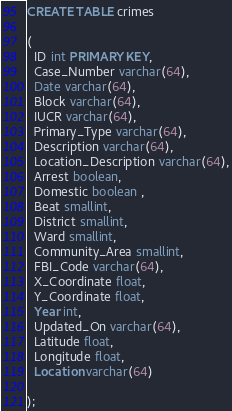Convert code to text. <code><loc_0><loc_0><loc_500><loc_500><_SQL_>CREATE TABLE crimes

(
  ID int PRIMARY KEY,
  Case_Number varchar(64),
  Date varchar(64),
  Block varchar(64),
  IUCR varchar(64),
  Primary_Type varchar(64),
  Description varchar(64),
  Location_Description varchar(64),
  Arrest boolean,
  Domestic boolean ,
  Beat smallint,
  District smallint,
  Ward smallint,
  Community_Area smallint,
  FBI_Code varchar(64),
  X_Coordinate float,
  Y_Coordinate float,
  Year int,
  Updated_On varchar(64),
  Latitude float,
  Longitude float,
  Location varchar(64)

);
</code> 